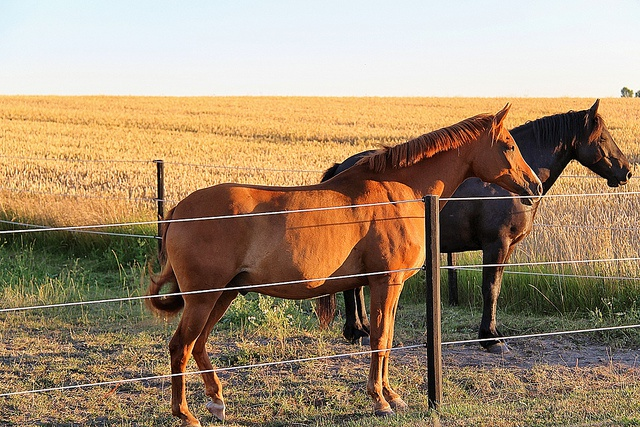Describe the objects in this image and their specific colors. I can see horse in lightblue, maroon, black, red, and brown tones and horse in lightblue, black, maroon, and brown tones in this image. 